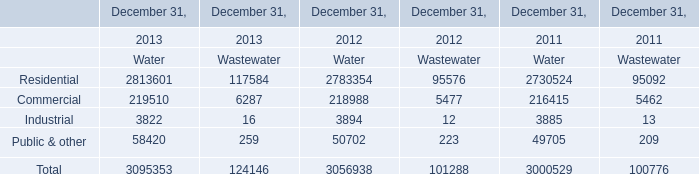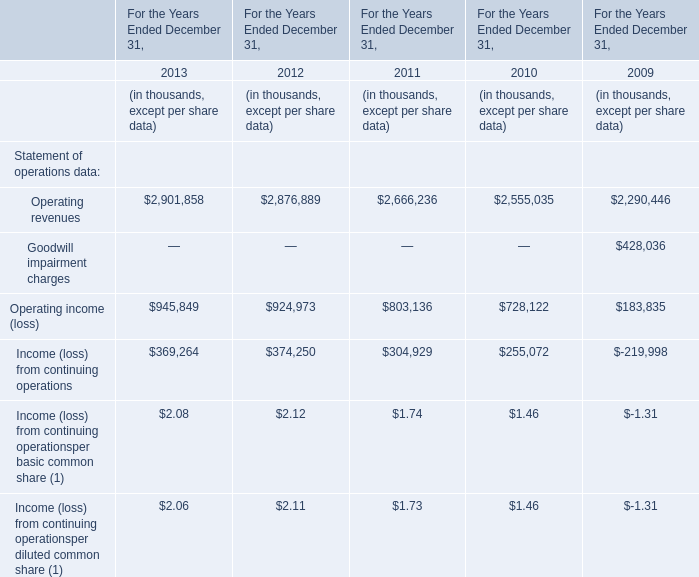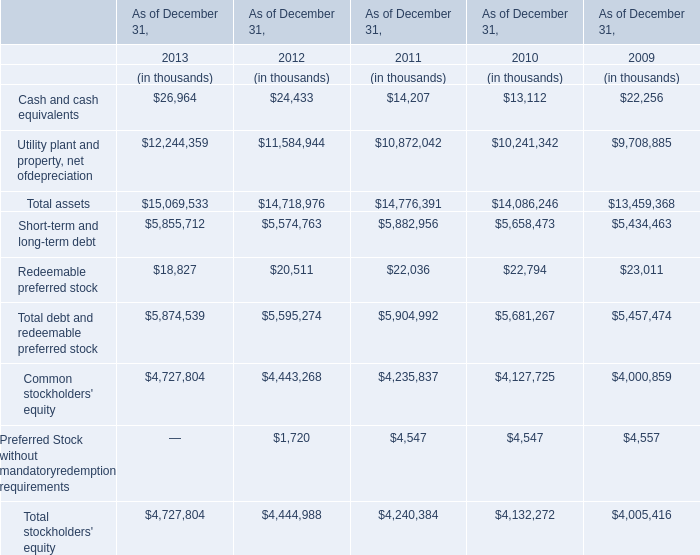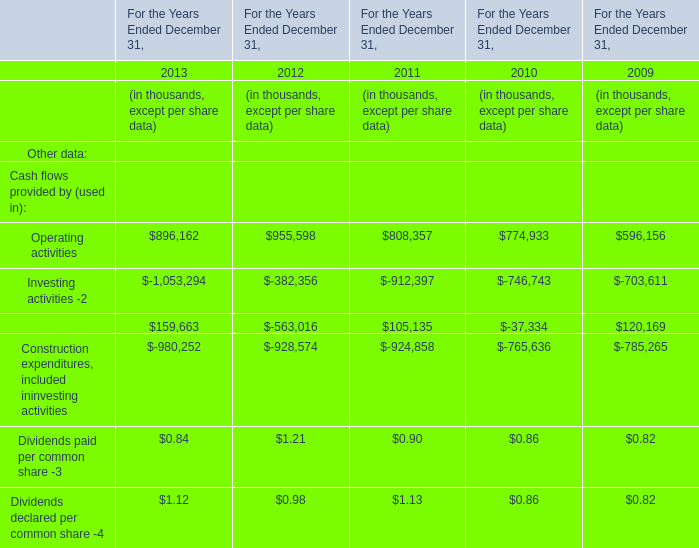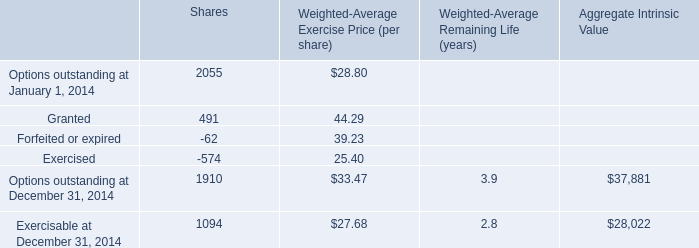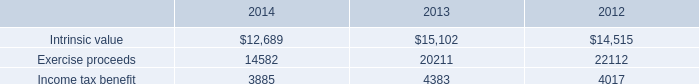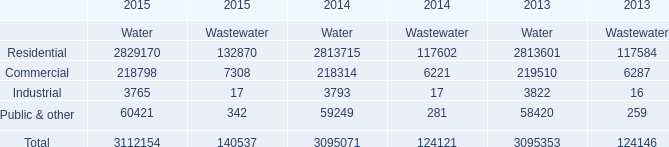How many Statement of operations data are greater than 100000 in 2013? 
Answer: 3. 